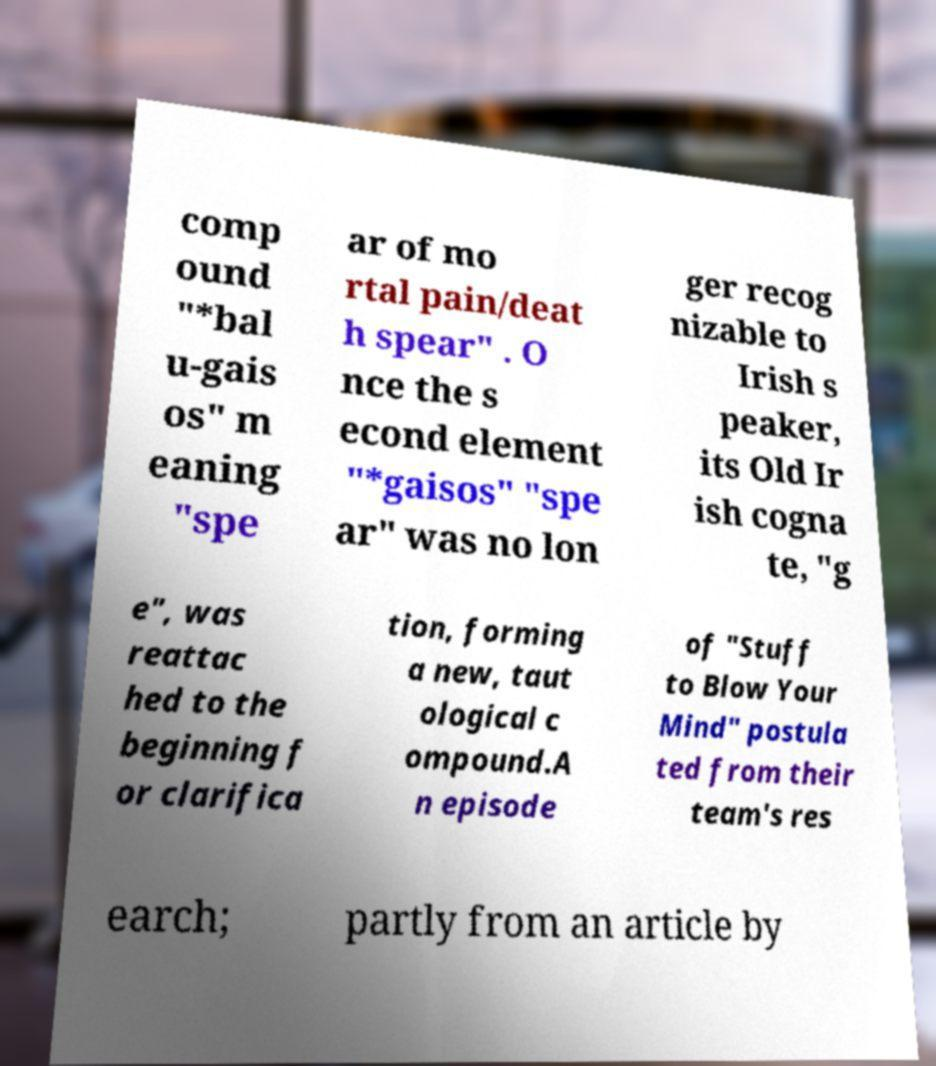I need the written content from this picture converted into text. Can you do that? comp ound "*bal u-gais os" m eaning "spe ar of mo rtal pain/deat h spear" . O nce the s econd element "*gaisos" "spe ar" was no lon ger recog nizable to Irish s peaker, its Old Ir ish cogna te, "g e", was reattac hed to the beginning f or clarifica tion, forming a new, taut ological c ompound.A n episode of "Stuff to Blow Your Mind" postula ted from their team's res earch; partly from an article by 